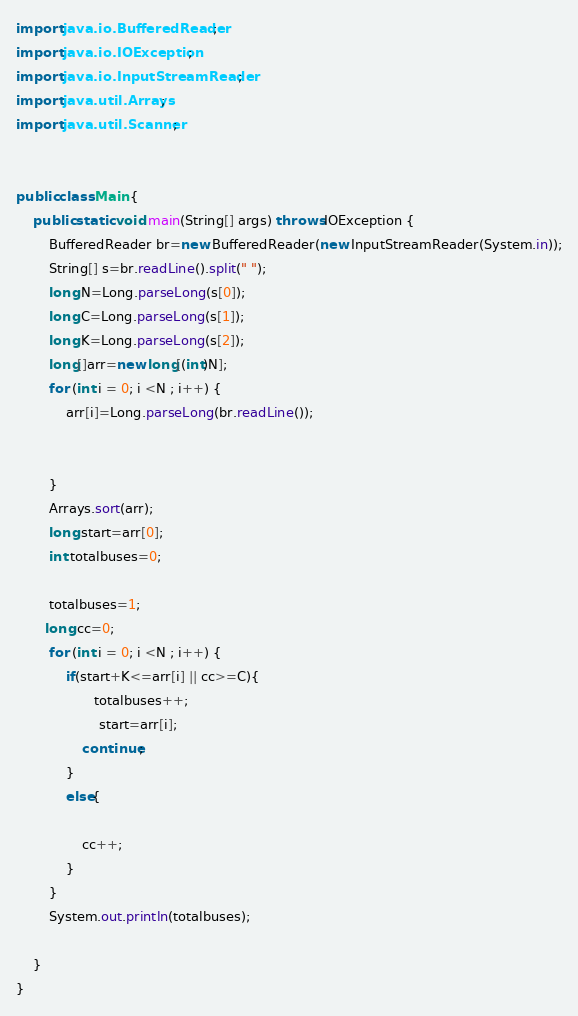Convert code to text. <code><loc_0><loc_0><loc_500><loc_500><_Java_>import java.io.BufferedReader;
import java.io.IOException;
import java.io.InputStreamReader;
import java.util.Arrays;
import java.util.Scanner;
 
 
public class Main {
    public static void main(String[] args) throws IOException {
        BufferedReader br=new BufferedReader(new InputStreamReader(System.in));
        String[] s=br.readLine().split(" ");
        long N=Long.parseLong(s[0]);
        long C=Long.parseLong(s[1]);
        long K=Long.parseLong(s[2]);
        long[]arr=new long[(int)N];
        for (int i = 0; i <N ; i++) {
            arr[i]=Long.parseLong(br.readLine());
 
 
        }
        Arrays.sort(arr);
        long start=arr[0];
        int totalbuses=0;
 
        totalbuses=1;
       long cc=0;
        for (int i = 0; i <N ; i++) {
            if(start+K<=arr[i] || cc>=C){
                   totalbuses++;
                    start=arr[i];
                continue;
            }
            else{
                
                cc++;
            }
        }
        System.out.println(totalbuses);
 
    }
}</code> 